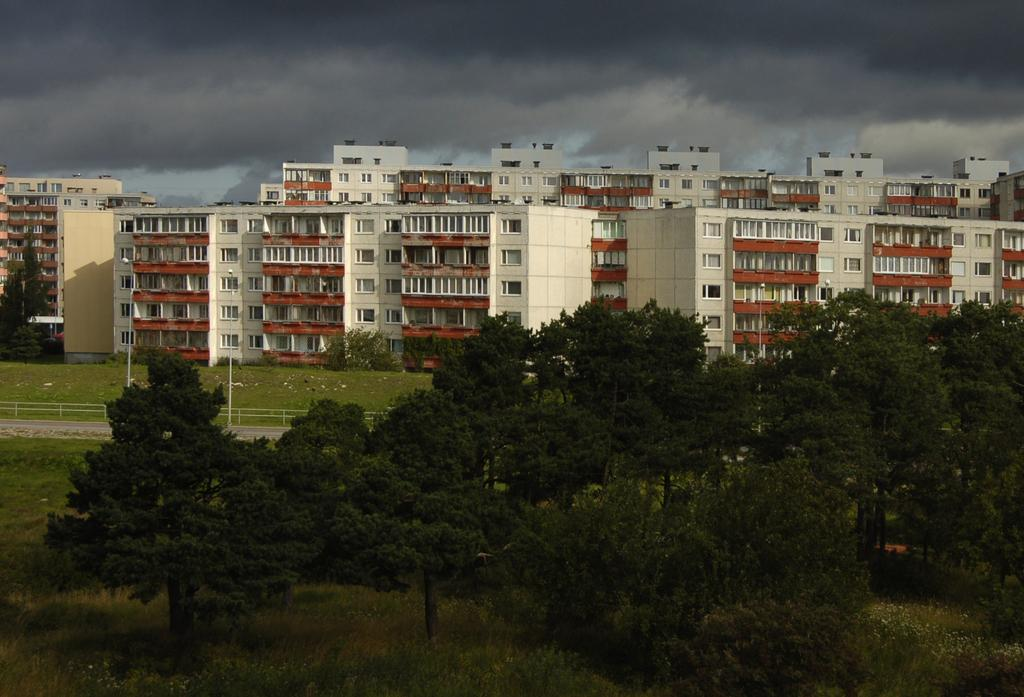What type of vegetation is present on the ground in the image? There are many trees on the ground in the image. What is the ground covered with? The ground is covered with grass. What can be seen in the background of the image? There are buildings visible in the background of the image. What is the condition of the sky in the image? The sky is cloudy in the image. What color is the ear of the person in the image? There is no person present in the image, so there is no ear to observe. 